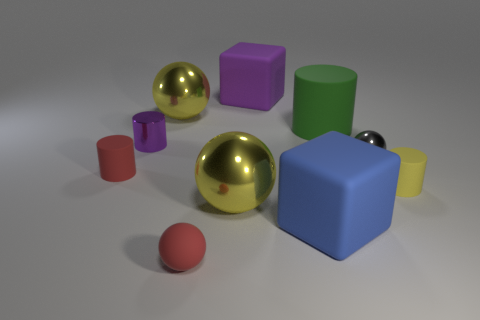Are there the same number of red things that are behind the red rubber cylinder and yellow cylinders? Upon reviewing the image, it appears that there is only one red object, which is a small red sphere, and it's located in front of both the red rubber cylinder and the yellow cylinders. Thus, the count of red objects behind each of these items would be zero since the red object is not behind them. 